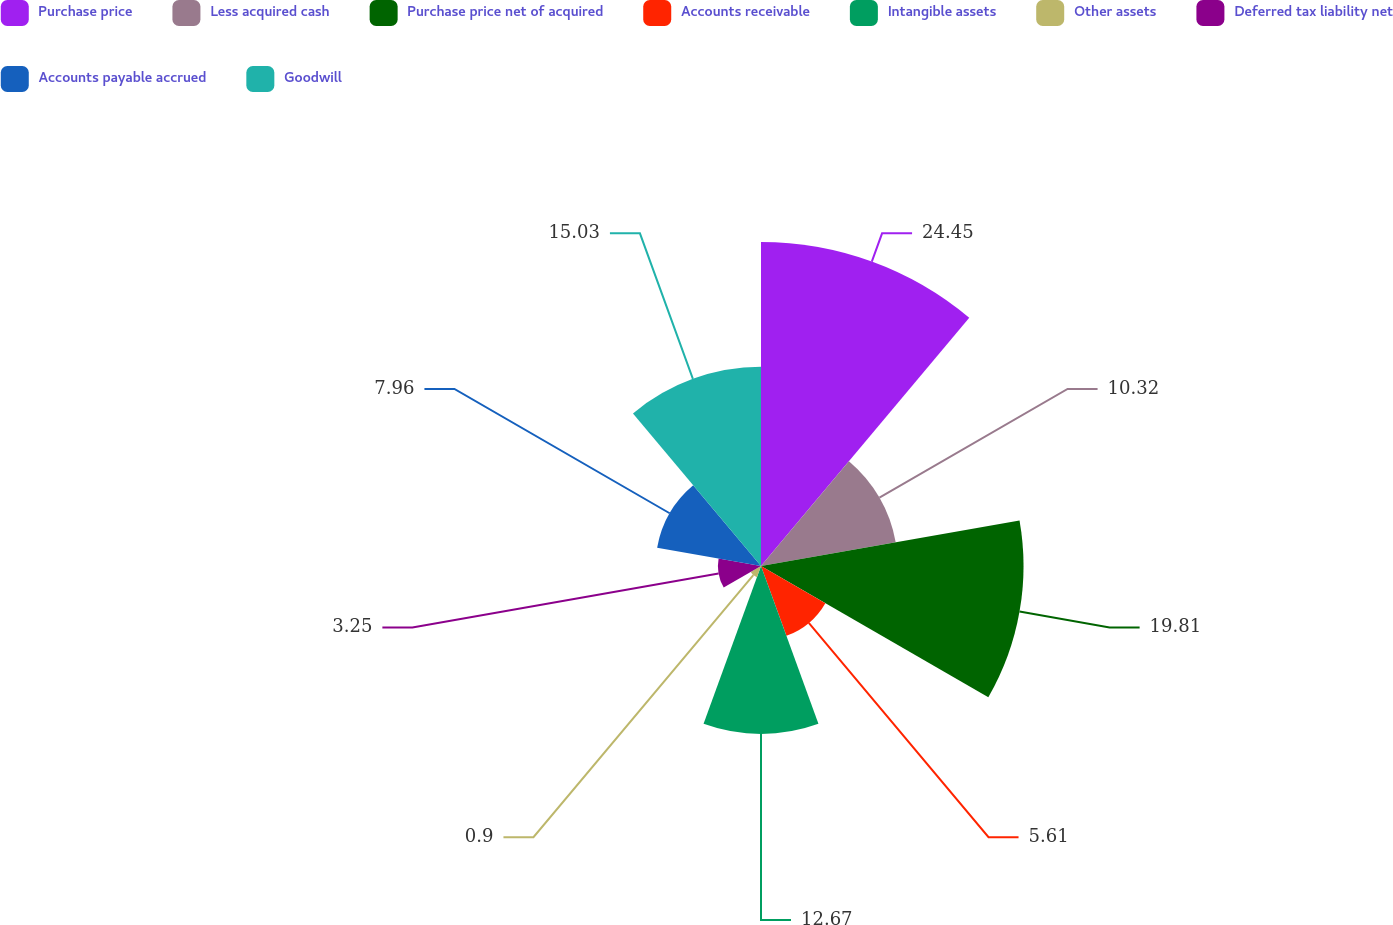Convert chart to OTSL. <chart><loc_0><loc_0><loc_500><loc_500><pie_chart><fcel>Purchase price<fcel>Less acquired cash<fcel>Purchase price net of acquired<fcel>Accounts receivable<fcel>Intangible assets<fcel>Other assets<fcel>Deferred tax liability net<fcel>Accounts payable accrued<fcel>Goodwill<nl><fcel>24.45%<fcel>10.32%<fcel>19.81%<fcel>5.61%<fcel>12.67%<fcel>0.9%<fcel>3.25%<fcel>7.96%<fcel>15.03%<nl></chart> 